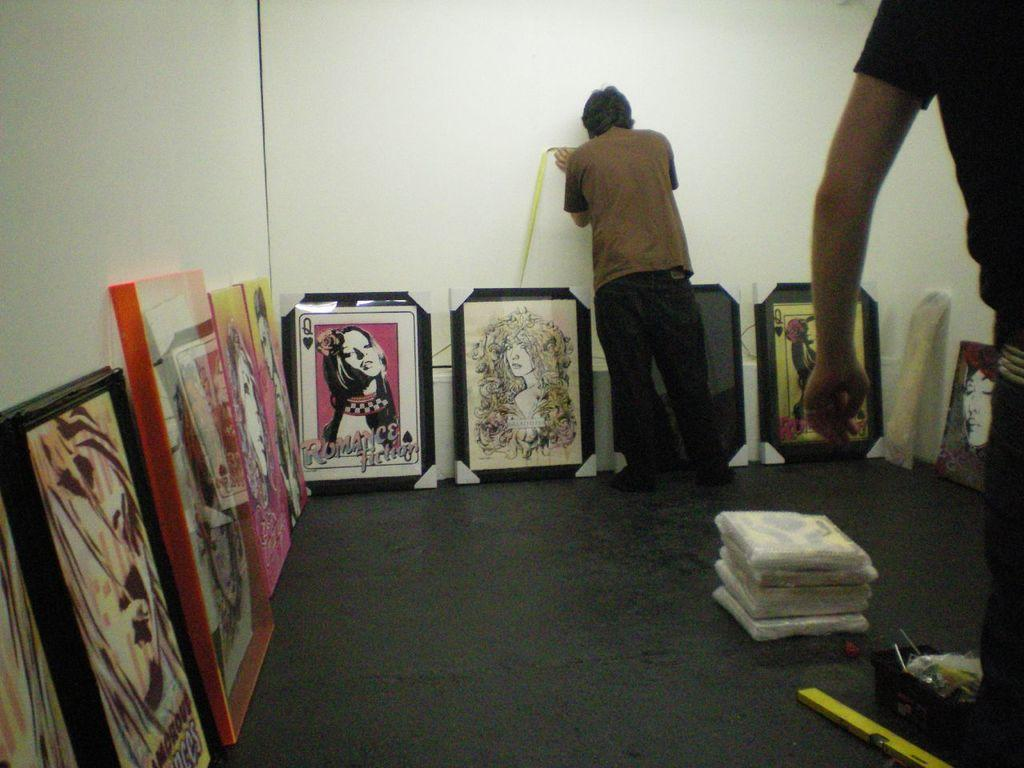<image>
Describe the image concisely. a poster of romance fiction among other posters 